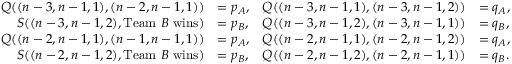Convert formula to latex. <formula><loc_0><loc_0><loc_500><loc_500>\begin{array} { r l r l } { Q ( ( n - 3 , n - 1 , 1 ) , ( n - 2 , n - 1 , 1 ) ) } & { = p _ { A } , } & { Q ( ( n - 3 , n - 1 , 1 ) , ( n - 3 , n - 1 , 2 ) ) } & { = q _ { A } , } \\ { S ( ( n - 3 , n - 1 , 2 ) , T e a m B w i n s ) } & { = p _ { B } , } & { Q ( ( n - 3 , n - 1 , 2 ) , ( n - 3 , n - 1 , 1 ) ) } & { = q _ { B } , } \\ { Q ( ( n - 2 , n - 1 , 1 ) , ( n - 1 , n - 1 , 1 ) ) } & { = p _ { A } , } & { Q ( ( n - 2 , n - 1 , 1 ) , ( n - 2 , n - 1 , 2 ) ) } & { = q _ { A } , } \\ { S ( ( n - 2 , n - 1 , 2 ) , T e a m B w i n s ) } & { = p _ { B } , } & { Q ( ( n - 2 , n - 1 , 2 ) , ( n - 2 , n - 1 , 1 ) ) } & { = q _ { B } . } \end{array}</formula> 